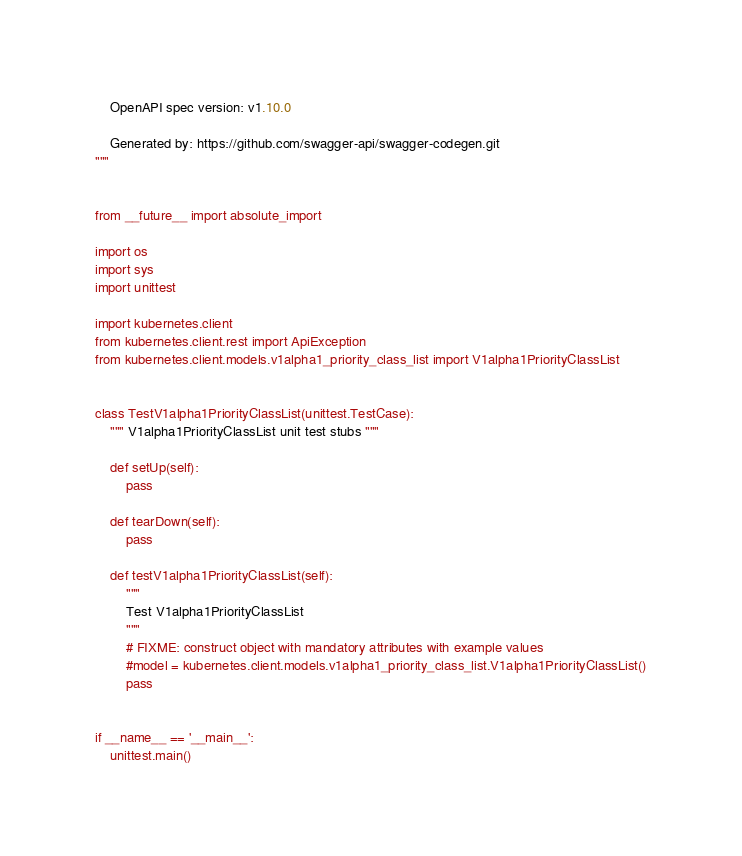Convert code to text. <code><loc_0><loc_0><loc_500><loc_500><_Python_>    OpenAPI spec version: v1.10.0
    
    Generated by: https://github.com/swagger-api/swagger-codegen.git
"""


from __future__ import absolute_import

import os
import sys
import unittest

import kubernetes.client
from kubernetes.client.rest import ApiException
from kubernetes.client.models.v1alpha1_priority_class_list import V1alpha1PriorityClassList


class TestV1alpha1PriorityClassList(unittest.TestCase):
    """ V1alpha1PriorityClassList unit test stubs """

    def setUp(self):
        pass

    def tearDown(self):
        pass

    def testV1alpha1PriorityClassList(self):
        """
        Test V1alpha1PriorityClassList
        """
        # FIXME: construct object with mandatory attributes with example values
        #model = kubernetes.client.models.v1alpha1_priority_class_list.V1alpha1PriorityClassList()
        pass


if __name__ == '__main__':
    unittest.main()
</code> 